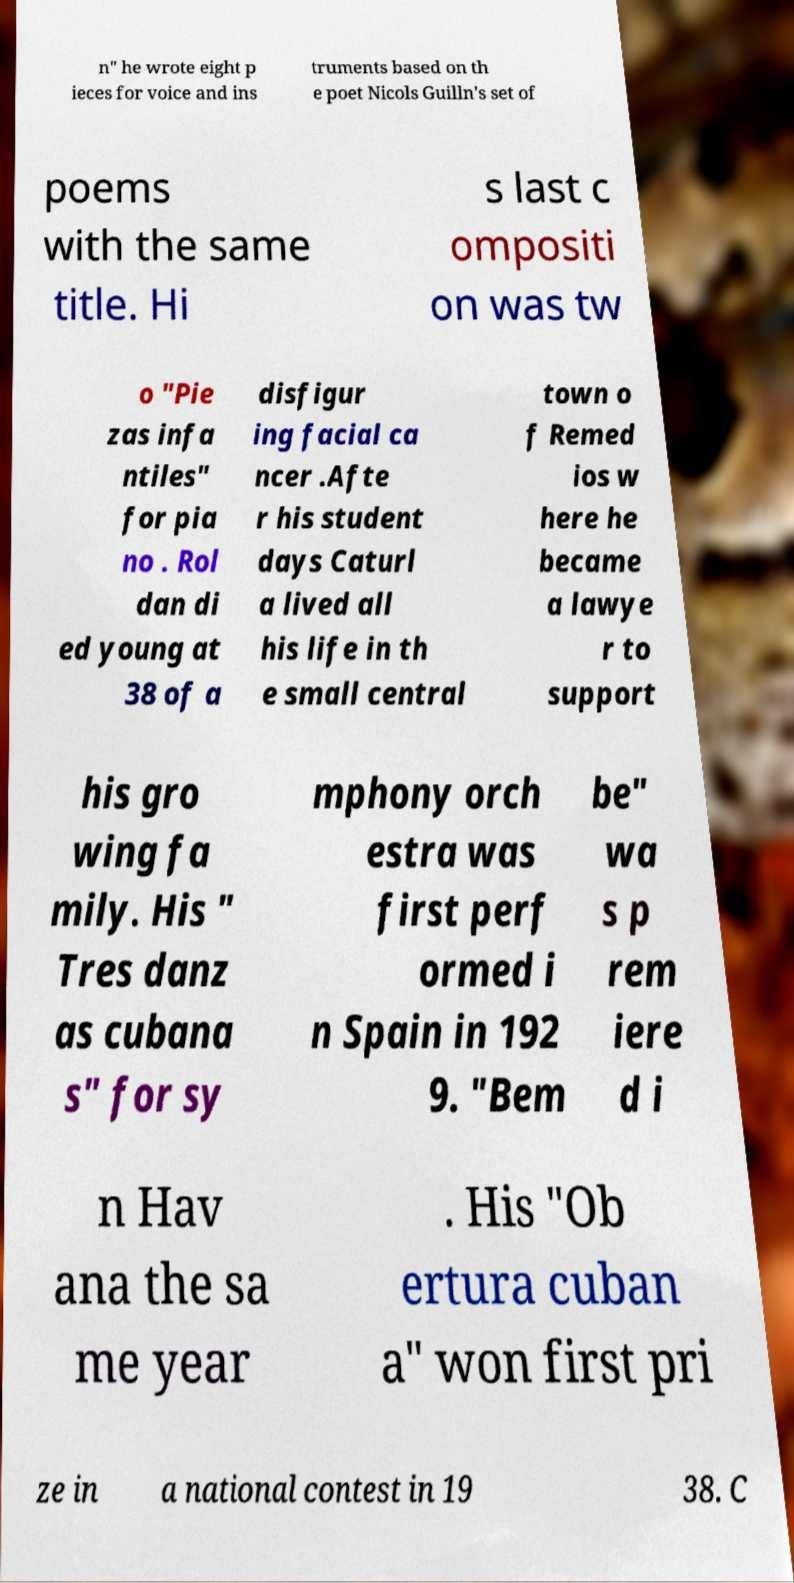For documentation purposes, I need the text within this image transcribed. Could you provide that? n" he wrote eight p ieces for voice and ins truments based on th e poet Nicols Guilln's set of poems with the same title. Hi s last c ompositi on was tw o "Pie zas infa ntiles" for pia no . Rol dan di ed young at 38 of a disfigur ing facial ca ncer .Afte r his student days Caturl a lived all his life in th e small central town o f Remed ios w here he became a lawye r to support his gro wing fa mily. His " Tres danz as cubana s" for sy mphony orch estra was first perf ormed i n Spain in 192 9. "Bem be" wa s p rem iere d i n Hav ana the sa me year . His "Ob ertura cuban a" won first pri ze in a national contest in 19 38. C 